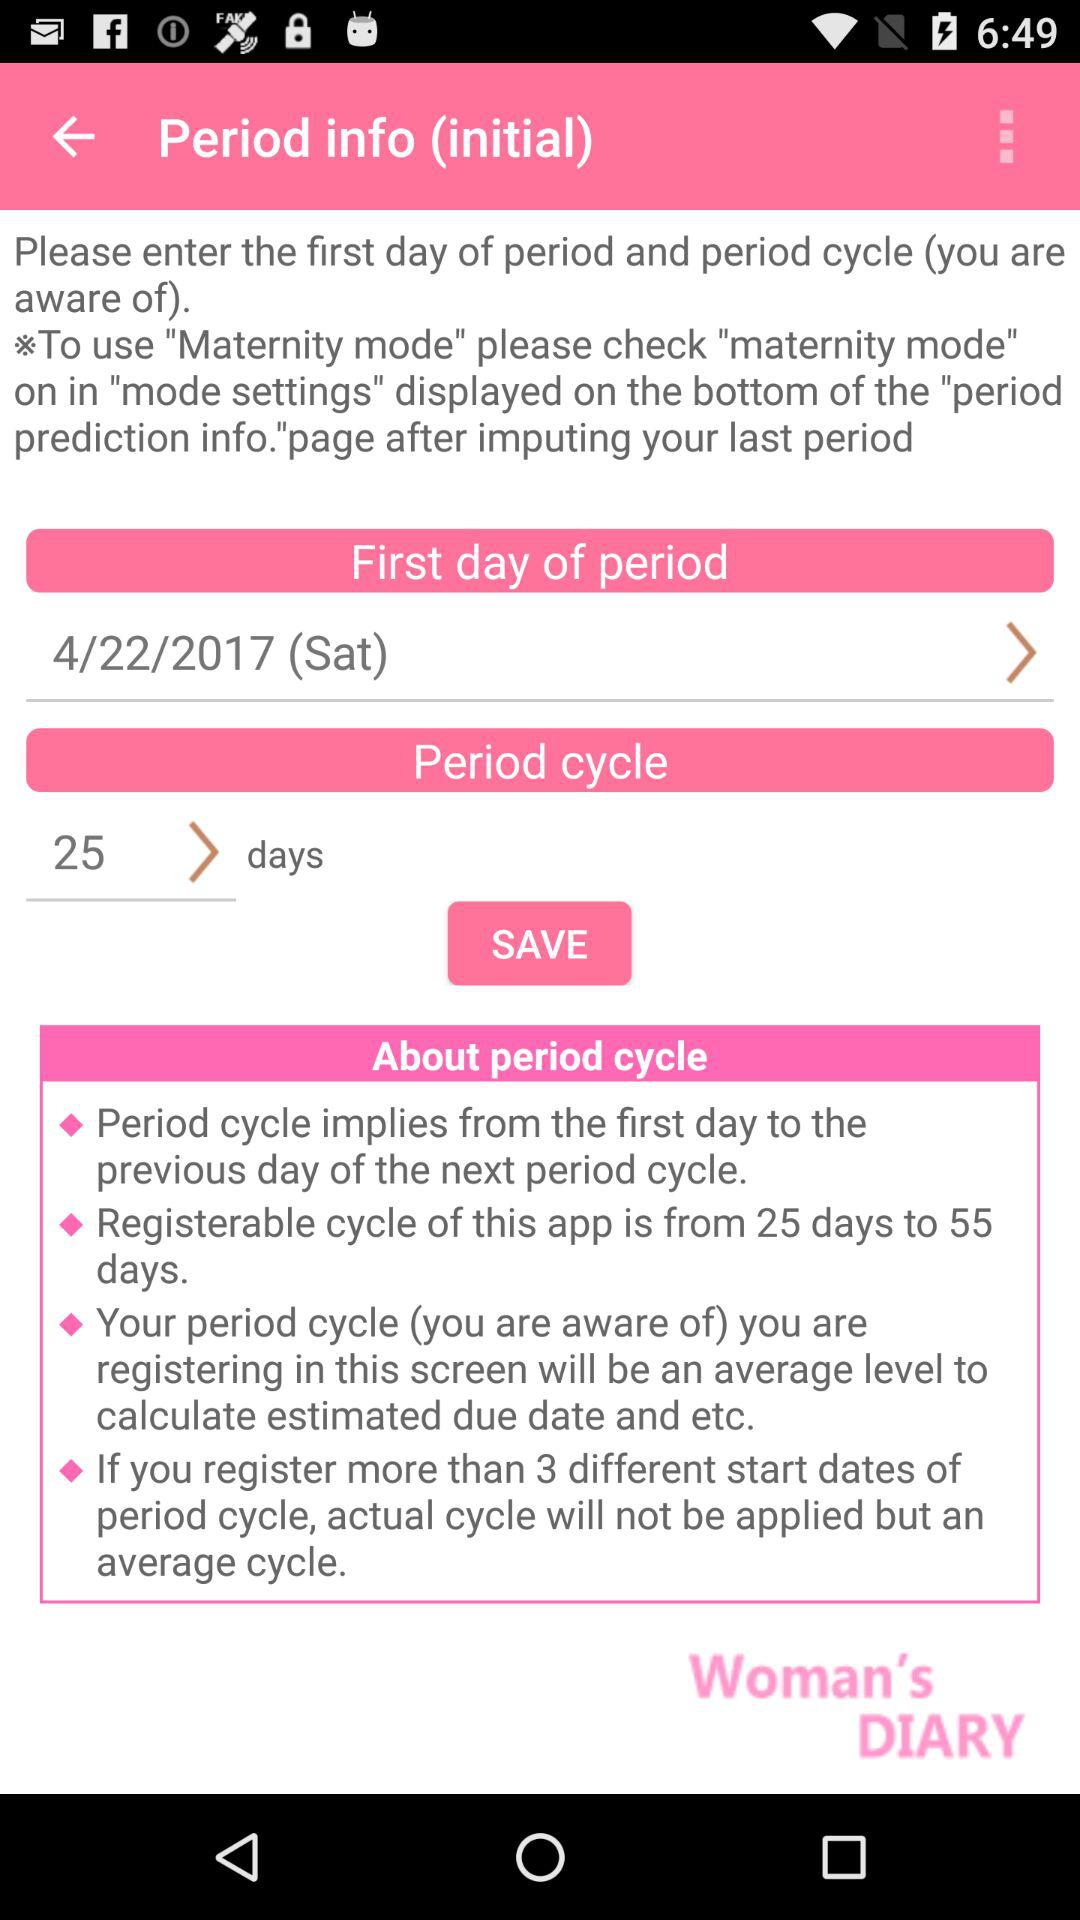What is the period cycle length? The period cycle length is 25 days. 